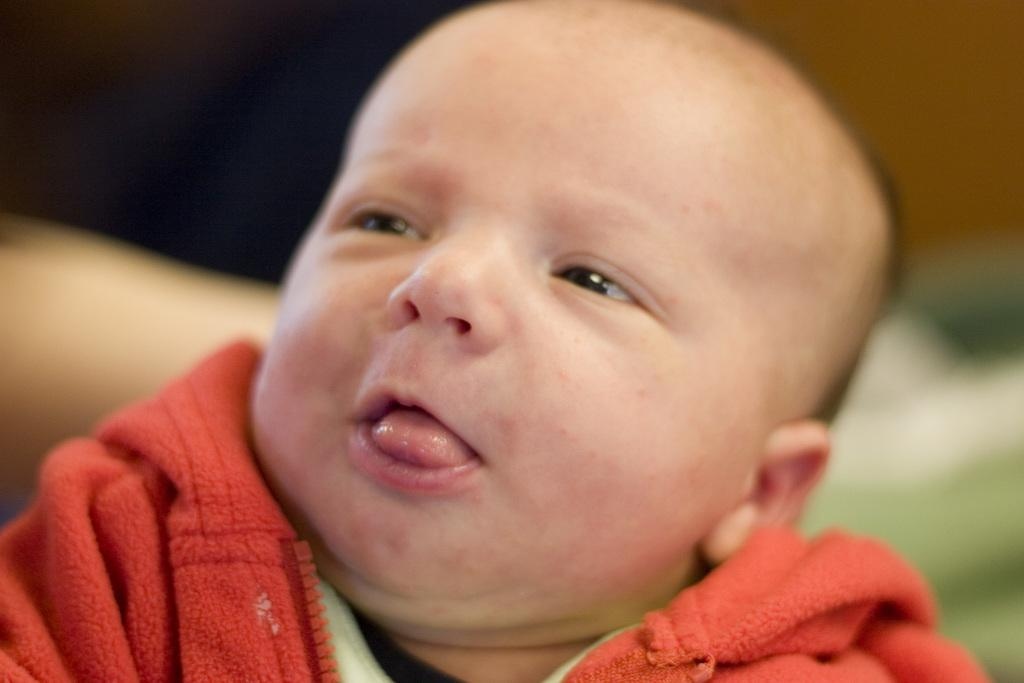What is the main subject of the image? There is a child in the image. What is the child wearing? The child is wearing a red jacket. Can you describe the background of the image? The background of the image is blurred. What type of example does the child provide in the image? There is no indication in the image that the child is providing an example, so it cannot be determined from the picture. 